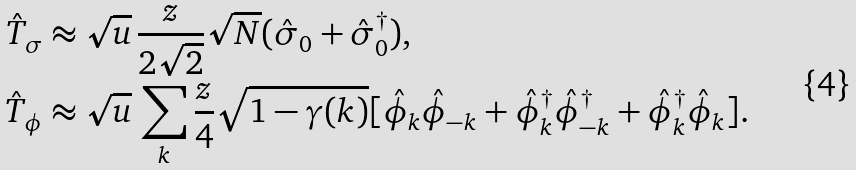<formula> <loc_0><loc_0><loc_500><loc_500>\hat { T } _ { \sigma } & \approx \sqrt { u } \, \frac { z } { 2 \sqrt { 2 } } \sqrt { N } ( \hat { \sigma } _ { 0 } + \hat { \sigma } _ { 0 } ^ { \dag } ) , \\ \hat { T } _ { \phi } & \approx \sqrt { u } \, \sum _ { k } \frac { z } { 4 } \sqrt { 1 - \gamma ( { k } ) } [ \hat { \phi } _ { k } \hat { \phi } _ { - { k } } + \hat { \phi } ^ { \dag } _ { k } \hat { \phi } ^ { \dag } _ { - { k } } + \hat { \phi } ^ { \dag } _ { k } \hat { \phi } _ { k } ] .</formula> 